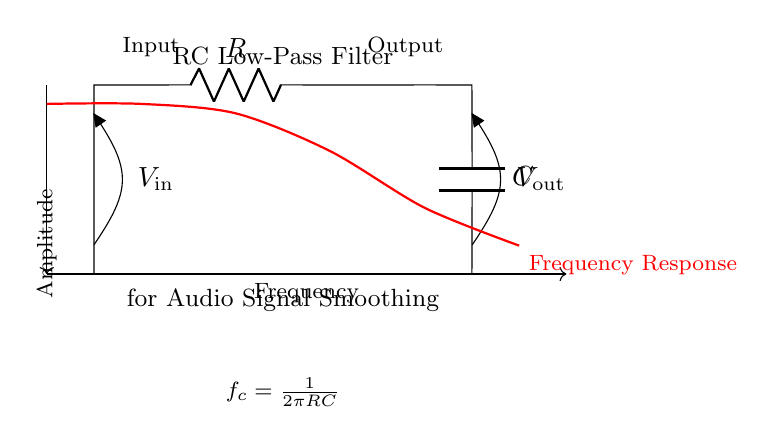What is the input voltage symbol in this circuit? The input voltage symbol is denoted as "V_in" and is visually represented at the top left of the circuit diagram, indicating the point where the input signal is applied.
Answer: V_in What type of filter is represented in this circuit? The circuit is an RC low-pass filter, which is indicated by the label at the top of the diagram and is designed to allow low-frequency signals to pass while attenuating high-frequency signals.
Answer: Low-pass filter How is the capacitor connected in the circuit? The capacitor is connected in parallel with the load (ground) after the resistor, which means one terminal of the capacitor is connected to the output node while the other terminal is connected to the ground, allowing it to perform smoothing of the output signal.
Answer: Parallel with load What is the cutoff frequency formula in this circuit? The cutoff frequency formula is provided in the circuit diagram as "f_c = 1/(2πRC)", which represents the frequency at which the output signal power drops to half of its maximum value, influenced by the resistor and capacitor values in the circuit.
Answer: f_c = 1/(2πRC) What happens to high frequencies in this RC low-pass filter? High frequencies are attenuated, meaning they are reduced in amplitude as they pass through the filter, which is the primary function of a low-pass filter like this one, allowing only lower frequencies to appear at the output.
Answer: Attenuated What is the role of the resistor in this circuit? The resistor controls the time constant of the circuit, determining how quickly the capacitor can charge and discharge, which affects the RC time constant and ultimately shapes the frequency response of the filter.
Answer: Time constant control What does the red line represent in the diagram? The red line represents the frequency response of the RC low-pass filter, showcasing how the amplitude of the output signal varies with frequency, indicating effective filtering behavior at different frequency ranges.
Answer: Frequency response 